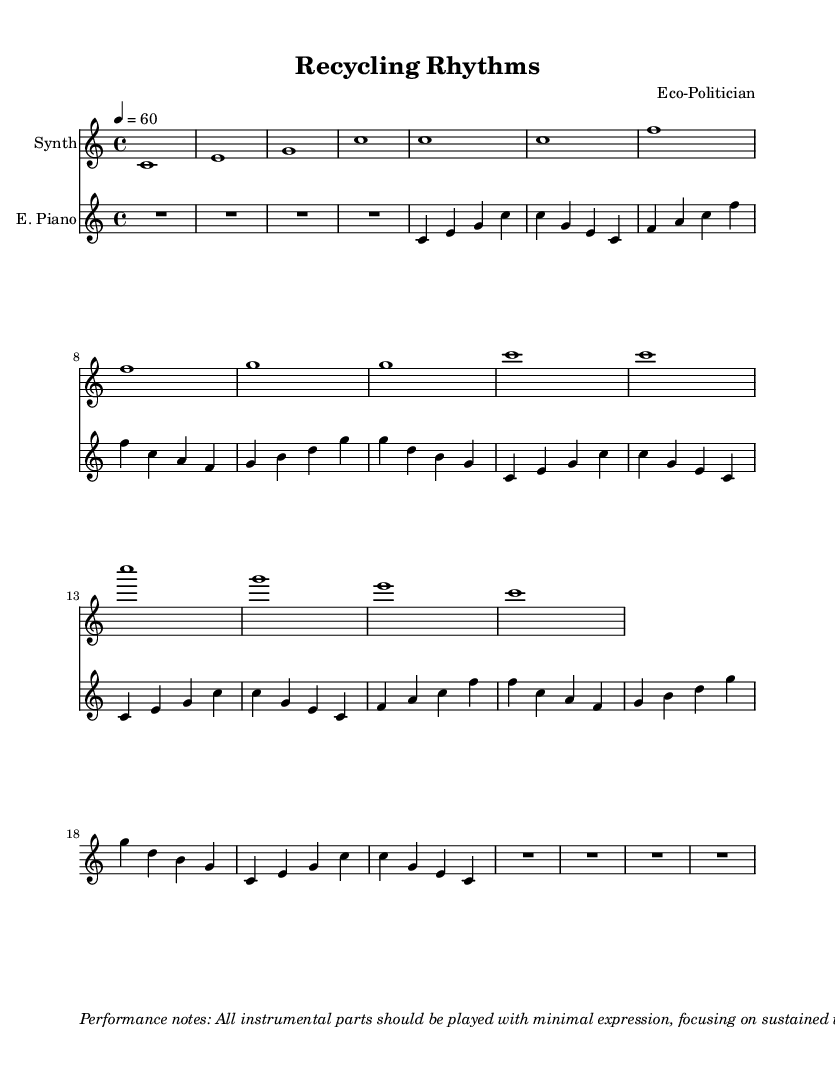What is the key signature of this music? The key signature is C major, which has no sharps or flats.
Answer: C major What is the time signature of the piece? The time signature indicated in the sheet music is 4/4, meaning there are four beats in each measure and a quarter note gets one beat.
Answer: 4/4 What is the tempo marking for this piece? The tempo marking provided in the sheet music is 60 beats per minute, indicated by "4 = 60," which means it is a moderate pace.
Answer: 60 How many measures are there in the main theme for the synthesizer? The main theme for the synthesizer is comprised of 8 measures, as indicated by the repeated notes and the structure of the piece.
Answer: 8 What role do field recordings play in this composition? Field recordings are intended to create a backdrop of industrial ambience, emphasizing the experimental nature of the piece and connecting to the theme of recycling.
Answer: Ambient backdrop What is the main characteristic of the performance style suggested for this piece? The performance style emphasizes minimal expression, focusing on sustained tones and gradual changes, which is typical in minimalist and ambient music.
Answer: Minimal expression What does the performance note suggest about the integration of field recordings? The performance note suggests that field recordings should be integrated seamlessly, which means they should blend smoothly with the instrumental parts instead of being abrupt or jarring.
Answer: Seamless integration 